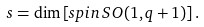<formula> <loc_0><loc_0><loc_500><loc_500>s = \dim \left [ s p i n \, S O ( 1 , q + 1 ) \right ] .</formula> 